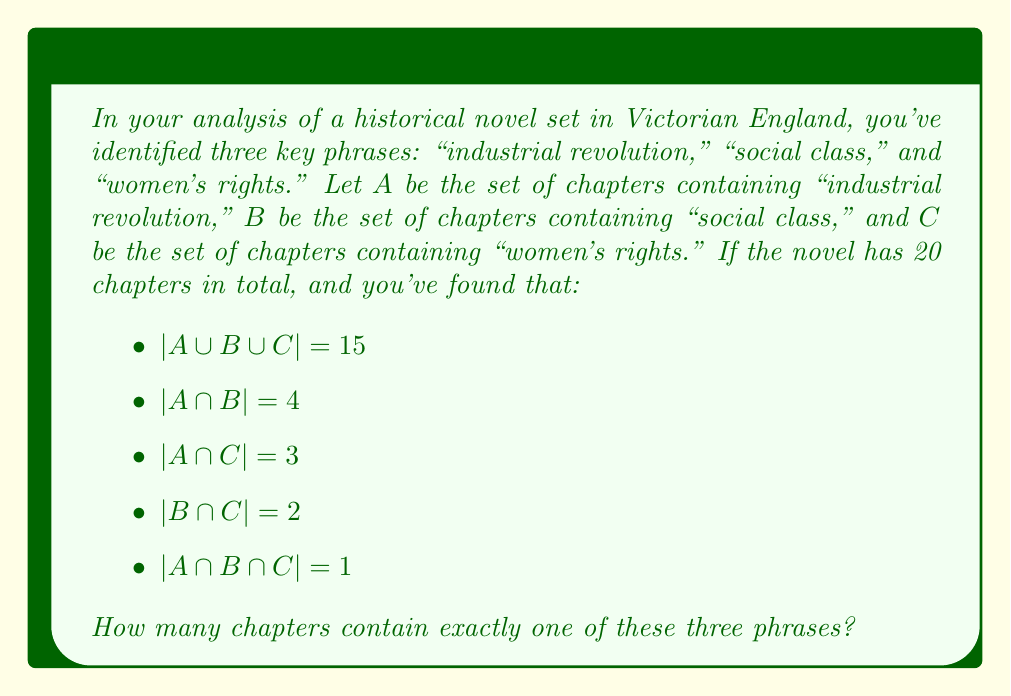Give your solution to this math problem. To solve this problem, we'll use the Inclusion-Exclusion Principle and set theory concepts. Let's break it down step by step:

1) First, let's recall the Inclusion-Exclusion Principle for three sets:

   $$|A \cup B \cup C| = |A| + |B| + |C| - |A \cap B| - |A \cap C| - |B \cap C| + |A \cap B \cap C|$$

2) We're given that $|A \cup B \cup C| = 15$, so let's substitute the known values:

   $$15 = |A| + |B| + |C| - 4 - 3 - 2 + 1$$

3) Simplify:

   $$23 = |A| + |B| + |C|$$

4) Now, we need to find the number of chapters containing exactly one phrase. Let's call this set $X$. We can express this as:

   $$|X| = |A \setminus (B \cup C)| + |B \setminus (A \cup C)| + |C \setminus (A \cup B)|$$

5) We can calculate each of these using the following formula:
   
   $$|A \setminus (B \cup C)| = |A| - |A \cap B| - |A \cap C| + |A \cap B \cap C|$$

6) Apply this to each set:

   $$|A \setminus (B \cup C)| = |A| - 4 - 3 + 1 = |A| - 6$$
   $$|B \setminus (A \cup C)| = |B| - 4 - 2 + 1 = |B| - 5$$
   $$|C \setminus (A \cup B)| = |C| - 3 - 2 + 1 = |C| - 4$$

7) Sum these up:

   $$|X| = (|A| - 6) + (|B| - 5) + (|C| - 4) = |A| + |B| + |C| - 15$$

8) We know from step 3 that $|A| + |B| + |C| = 23$, so:

   $$|X| = 23 - 15 = 8$$

Therefore, 8 chapters contain exactly one of these three phrases.
Answer: 8 chapters 